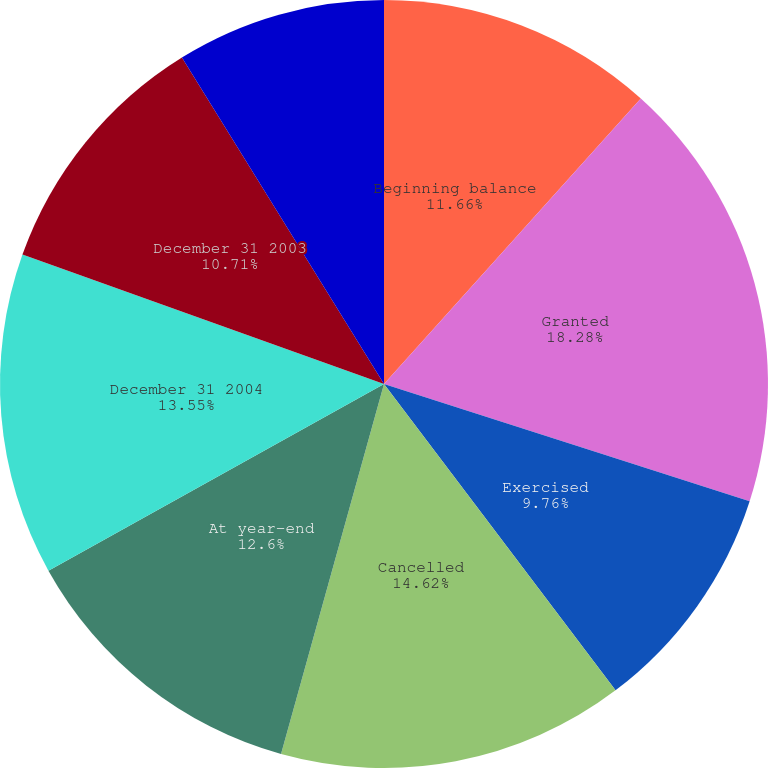<chart> <loc_0><loc_0><loc_500><loc_500><pie_chart><fcel>Beginning balance<fcel>Granted<fcel>Exercised<fcel>Cancelled<fcel>At year-end<fcel>December 31 2004<fcel>December 31 2003<fcel>December 31 2002<nl><fcel>11.66%<fcel>18.28%<fcel>9.76%<fcel>14.62%<fcel>12.6%<fcel>13.55%<fcel>10.71%<fcel>8.82%<nl></chart> 